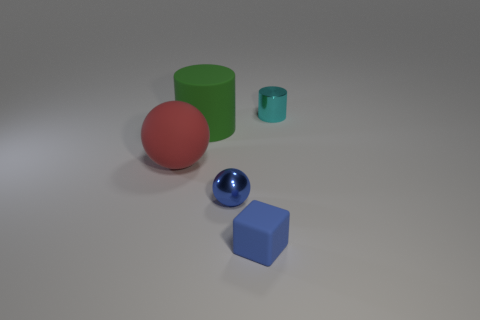Is there anything else that is the same shape as the blue matte object?
Give a very brief answer. No. There is a cylinder that is to the left of the tiny cyan shiny cylinder; what is it made of?
Your answer should be compact. Rubber. There is a ball that is on the left side of the metallic object that is in front of the cyan metallic object; how big is it?
Your answer should be very brief. Large. How many cyan metallic cylinders have the same size as the block?
Your response must be concise. 1. There is a thing that is behind the green cylinder; is it the same color as the block that is left of the small cyan object?
Provide a short and direct response. No. There is a red thing; are there any matte things to the right of it?
Give a very brief answer. Yes. What color is the small thing that is both right of the small blue shiny ball and in front of the red thing?
Give a very brief answer. Blue. Is there a small rubber object that has the same color as the tiny sphere?
Keep it short and to the point. Yes. Does the sphere that is on the left side of the big green matte object have the same material as the cylinder that is to the left of the blue cube?
Your answer should be compact. Yes. There is a metal object behind the tiny blue ball; how big is it?
Make the answer very short. Small. 